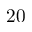Convert formula to latex. <formula><loc_0><loc_0><loc_500><loc_500>2 0</formula> 